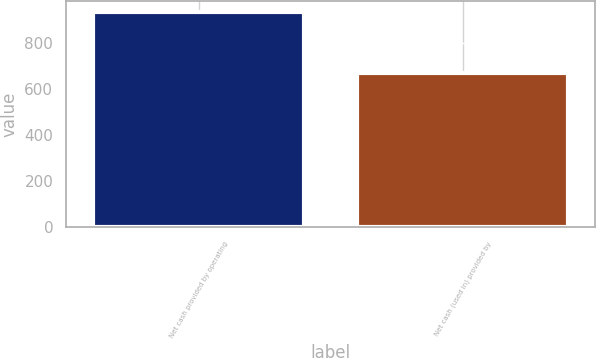<chart> <loc_0><loc_0><loc_500><loc_500><bar_chart><fcel>Net cash provided by operating<fcel>Net cash (used in) provided by<nl><fcel>934.4<fcel>669.8<nl></chart> 